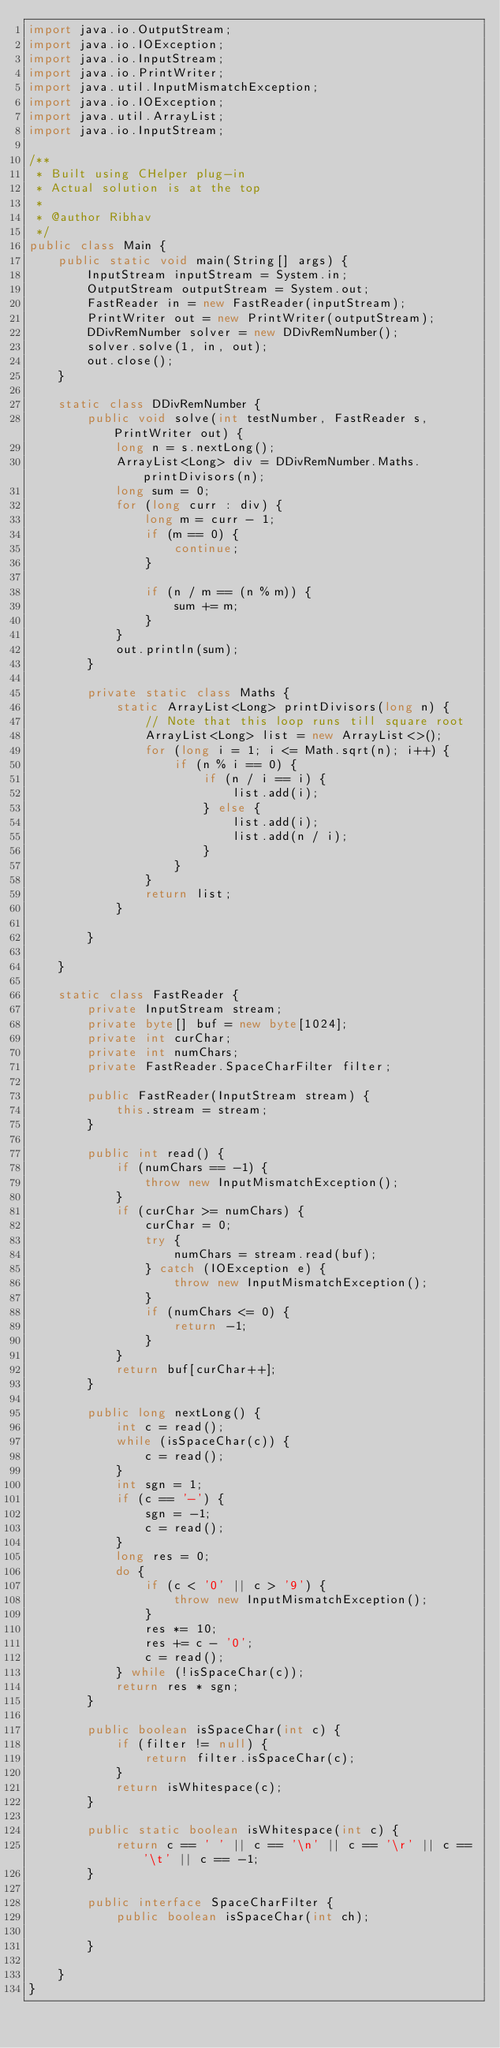Convert code to text. <code><loc_0><loc_0><loc_500><loc_500><_Java_>import java.io.OutputStream;
import java.io.IOException;
import java.io.InputStream;
import java.io.PrintWriter;
import java.util.InputMismatchException;
import java.io.IOException;
import java.util.ArrayList;
import java.io.InputStream;

/**
 * Built using CHelper plug-in
 * Actual solution is at the top
 *
 * @author Ribhav
 */
public class Main {
    public static void main(String[] args) {
        InputStream inputStream = System.in;
        OutputStream outputStream = System.out;
        FastReader in = new FastReader(inputStream);
        PrintWriter out = new PrintWriter(outputStream);
        DDivRemNumber solver = new DDivRemNumber();
        solver.solve(1, in, out);
        out.close();
    }

    static class DDivRemNumber {
        public void solve(int testNumber, FastReader s, PrintWriter out) {
            long n = s.nextLong();
            ArrayList<Long> div = DDivRemNumber.Maths.printDivisors(n);
            long sum = 0;
            for (long curr : div) {
                long m = curr - 1;
                if (m == 0) {
                    continue;
                }

                if (n / m == (n % m)) {
                    sum += m;
                }
            }
            out.println(sum);
        }

        private static class Maths {
            static ArrayList<Long> printDivisors(long n) {
                // Note that this loop runs till square root
                ArrayList<Long> list = new ArrayList<>();
                for (long i = 1; i <= Math.sqrt(n); i++) {
                    if (n % i == 0) {
                        if (n / i == i) {
                            list.add(i);
                        } else {
                            list.add(i);
                            list.add(n / i);
                        }
                    }
                }
                return list;
            }

        }

    }

    static class FastReader {
        private InputStream stream;
        private byte[] buf = new byte[1024];
        private int curChar;
        private int numChars;
        private FastReader.SpaceCharFilter filter;

        public FastReader(InputStream stream) {
            this.stream = stream;
        }

        public int read() {
            if (numChars == -1) {
                throw new InputMismatchException();
            }
            if (curChar >= numChars) {
                curChar = 0;
                try {
                    numChars = stream.read(buf);
                } catch (IOException e) {
                    throw new InputMismatchException();
                }
                if (numChars <= 0) {
                    return -1;
                }
            }
            return buf[curChar++];
        }

        public long nextLong() {
            int c = read();
            while (isSpaceChar(c)) {
                c = read();
            }
            int sgn = 1;
            if (c == '-') {
                sgn = -1;
                c = read();
            }
            long res = 0;
            do {
                if (c < '0' || c > '9') {
                    throw new InputMismatchException();
                }
                res *= 10;
                res += c - '0';
                c = read();
            } while (!isSpaceChar(c));
            return res * sgn;
        }

        public boolean isSpaceChar(int c) {
            if (filter != null) {
                return filter.isSpaceChar(c);
            }
            return isWhitespace(c);
        }

        public static boolean isWhitespace(int c) {
            return c == ' ' || c == '\n' || c == '\r' || c == '\t' || c == -1;
        }

        public interface SpaceCharFilter {
            public boolean isSpaceChar(int ch);

        }

    }
}

</code> 